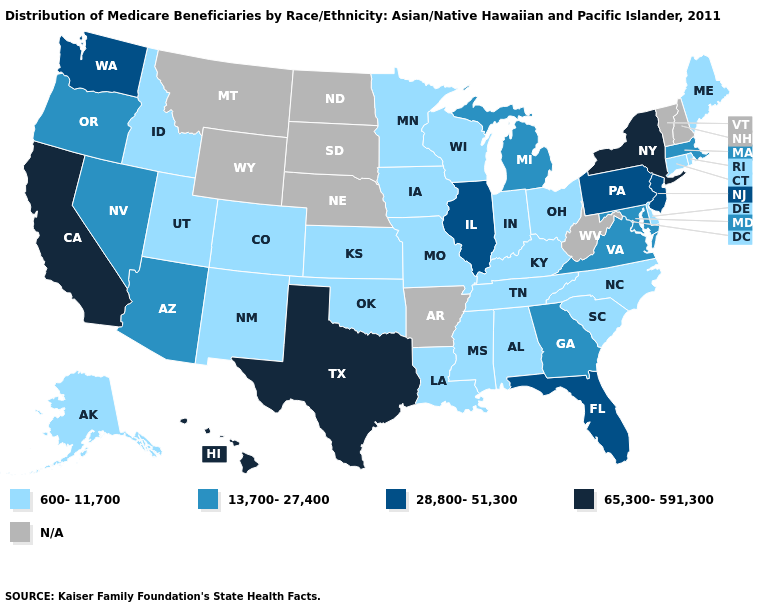Which states hav the highest value in the Northeast?
Be succinct. New York. What is the value of Ohio?
Short answer required. 600-11,700. Does the map have missing data?
Be succinct. Yes. Among the states that border Louisiana , which have the lowest value?
Write a very short answer. Mississippi. Does New York have the highest value in the USA?
Write a very short answer. Yes. What is the value of North Carolina?
Be succinct. 600-11,700. How many symbols are there in the legend?
Give a very brief answer. 5. Name the states that have a value in the range 600-11,700?
Answer briefly. Alabama, Alaska, Colorado, Connecticut, Delaware, Idaho, Indiana, Iowa, Kansas, Kentucky, Louisiana, Maine, Minnesota, Mississippi, Missouri, New Mexico, North Carolina, Ohio, Oklahoma, Rhode Island, South Carolina, Tennessee, Utah, Wisconsin. Name the states that have a value in the range 28,800-51,300?
Be succinct. Florida, Illinois, New Jersey, Pennsylvania, Washington. Name the states that have a value in the range 28,800-51,300?
Write a very short answer. Florida, Illinois, New Jersey, Pennsylvania, Washington. Does Hawaii have the highest value in the West?
Give a very brief answer. Yes. What is the value of California?
Quick response, please. 65,300-591,300. Which states hav the highest value in the South?
Concise answer only. Texas. 